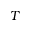Convert formula to latex. <formula><loc_0><loc_0><loc_500><loc_500>T</formula> 